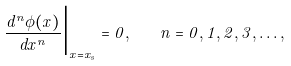Convert formula to latex. <formula><loc_0><loc_0><loc_500><loc_500>\frac { d ^ { n } \phi ( x ) } { d x ^ { n } } \Big { | } _ { x = x _ { s } } = 0 , \quad n = 0 , 1 , 2 , 3 , \dots ,</formula> 